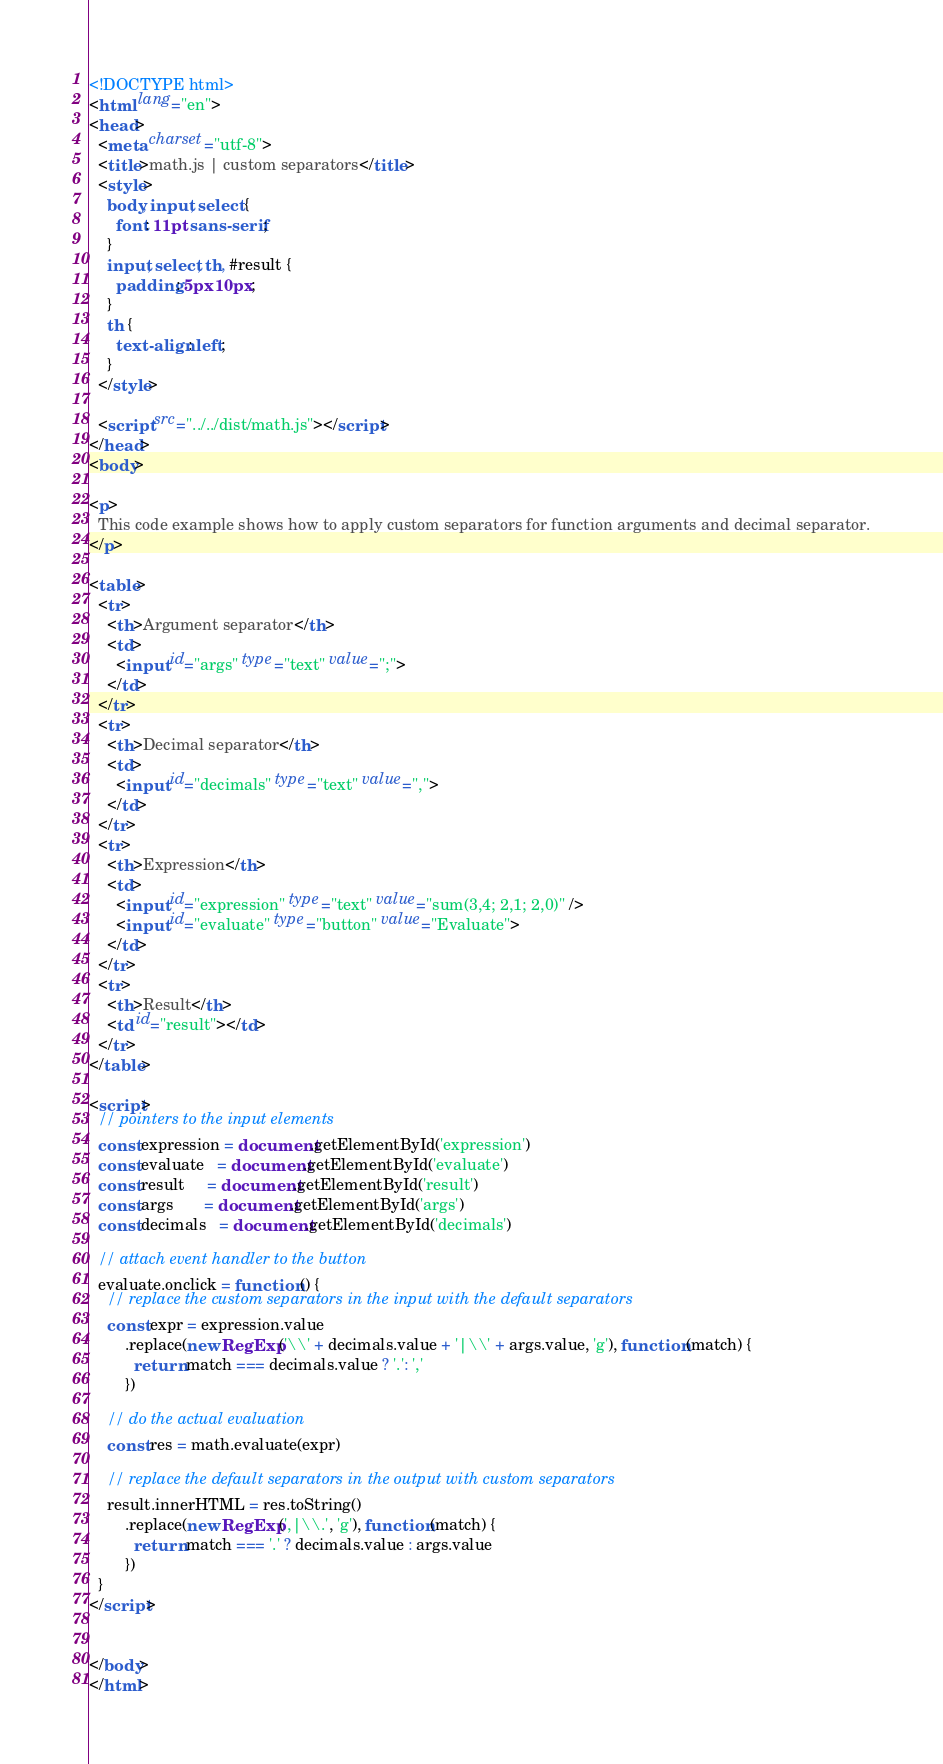Convert code to text. <code><loc_0><loc_0><loc_500><loc_500><_HTML_><!DOCTYPE html>
<html lang="en">
<head>
  <meta charset="utf-8">
  <title>math.js | custom separators</title>
  <style>
    body, input, select {
      font: 11pt sans-serif;
    }
    input, select, th, #result {
      padding: 5px 10px;
    }
    th {
      text-align: left;
    }
  </style>

  <script src="../../dist/math.js"></script>
</head>
<body>

<p>
  This code example shows how to apply custom separators for function arguments and decimal separator.
</p>

<table>
  <tr>
    <th>Argument separator</th>
    <td>
      <input id="args" type="text" value=";">
    </td>
  </tr>
  <tr>
    <th>Decimal separator</th>
    <td>
      <input id="decimals" type="text" value=",">
    </td>
  </tr>
  <tr>
    <th>Expression</th>
    <td>
      <input id="expression" type="text" value="sum(3,4; 2,1; 2,0)" />
      <input id="evaluate" type="button" value="Evaluate">
    </td>
  </tr>
  <tr>
    <th>Result</th>
    <td id="result"></td>
  </tr>
</table>

<script>
  // pointers to the input elements
  const expression = document.getElementById('expression')
  const evaluate   = document.getElementById('evaluate')
  const result     = document.getElementById('result')
  const args       = document.getElementById('args')
  const decimals   = document.getElementById('decimals')

  // attach event handler to the button
  evaluate.onclick = function () {
    // replace the custom separators in the input with the default separators
    const expr = expression.value
        .replace(new RegExp('\\' + decimals.value + '|\\' + args.value, 'g'), function (match) {
          return match === decimals.value ? '.': ','
        })

    // do the actual evaluation
    const res = math.evaluate(expr)

    // replace the default separators in the output with custom separators
    result.innerHTML = res.toString()
        .replace(new RegExp(',|\\.', 'g'), function (match) {
          return match === '.' ? decimals.value : args.value
        })
  }
</script>


</body>
</html></code> 